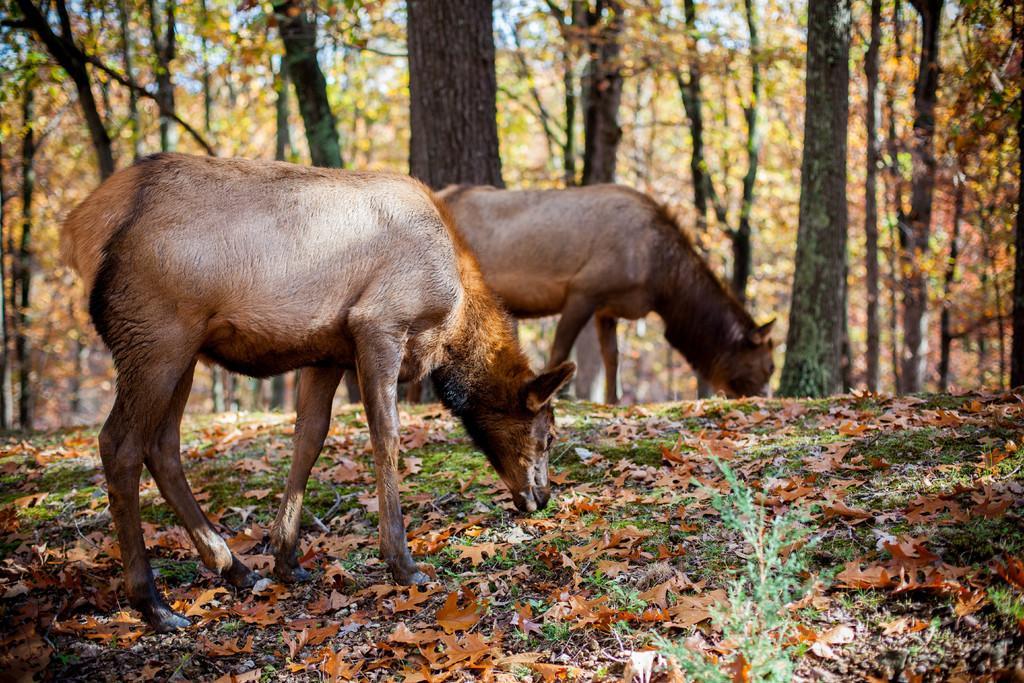How would you summarize this image in a sentence or two? In this image we can see two animals. On the ground there are dried leaves. In the background there are a number of trees. Through trees sky is visible. In-front of the image there is a plant.   